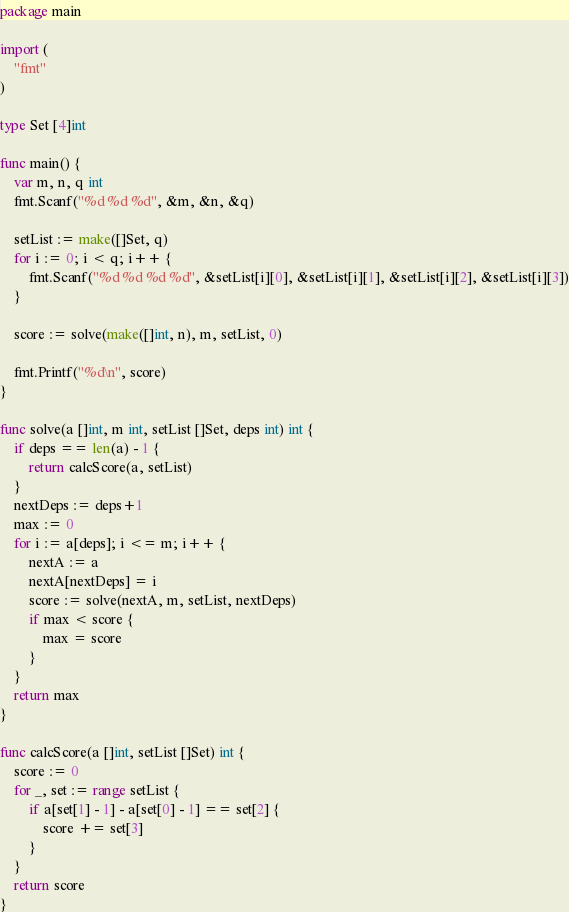<code> <loc_0><loc_0><loc_500><loc_500><_Go_>package main

import (
	"fmt"
)

type Set [4]int

func main() {
	var m, n, q int
	fmt.Scanf("%d %d %d", &m, &n, &q)

	setList := make([]Set, q)
	for i := 0; i < q; i++ {
		fmt.Scanf("%d %d %d %d", &setList[i][0], &setList[i][1], &setList[i][2], &setList[i][3])
	}

	score := solve(make([]int, n), m, setList, 0)

	fmt.Printf("%d\n", score)
}

func solve(a []int, m int, setList []Set, deps int) int {
	if deps == len(a) - 1 {
		return calcScore(a, setList)
	}
	nextDeps := deps+1
	max := 0
	for i := a[deps]; i <= m; i++ {
		nextA := a
		nextA[nextDeps] = i
		score := solve(nextA, m, setList, nextDeps)
		if max < score {
			max = score
		}
	}
	return max
}

func calcScore(a []int, setList []Set) int {
	score := 0
	for _, set := range setList {
		if a[set[1] - 1] - a[set[0] - 1] == set[2] {
			score += set[3]
		}
	}
	return score
}
</code> 